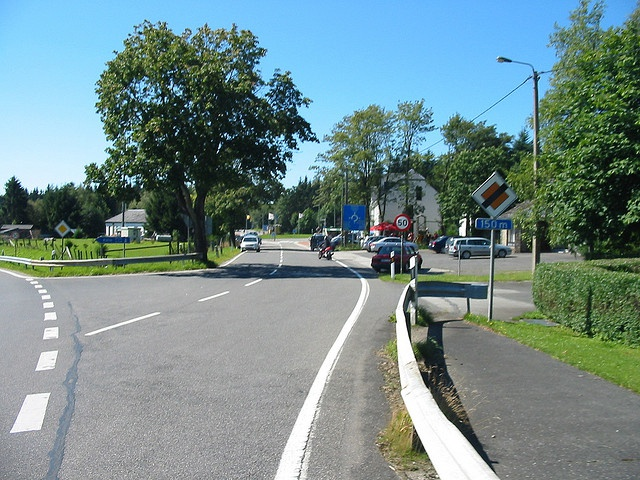Describe the objects in this image and their specific colors. I can see car in lightblue, black, gray, blue, and darkblue tones, car in lightblue, black, blue, navy, and gray tones, car in lightblue, black, gray, blue, and darkblue tones, car in lightblue, white, gray, black, and darkgray tones, and car in lightblue, gray, black, and white tones in this image. 